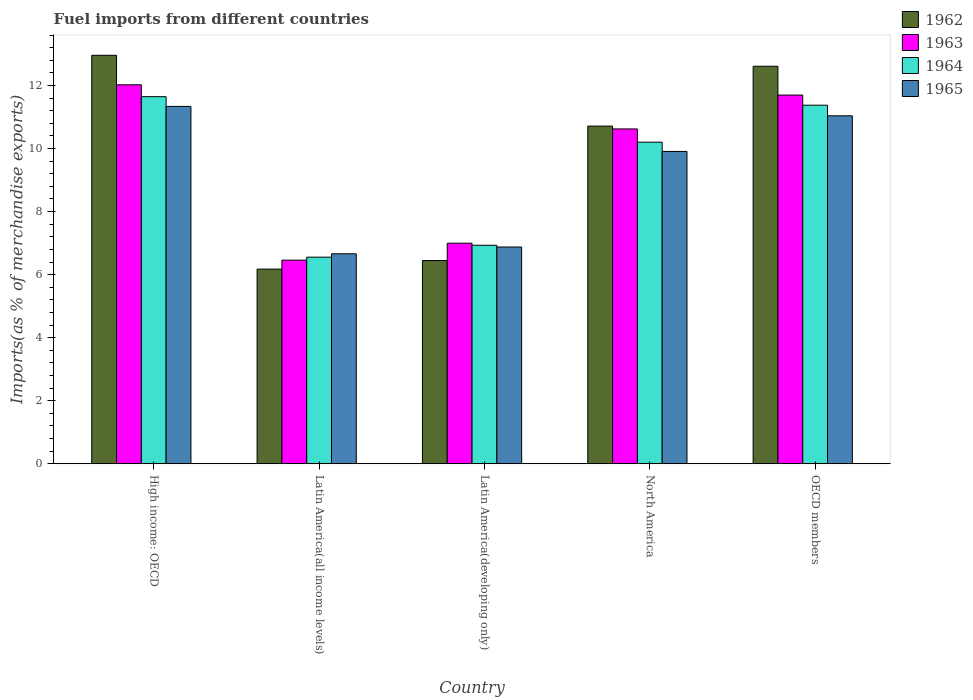How many different coloured bars are there?
Keep it short and to the point. 4. How many groups of bars are there?
Give a very brief answer. 5. Are the number of bars per tick equal to the number of legend labels?
Keep it short and to the point. Yes. How many bars are there on the 3rd tick from the right?
Give a very brief answer. 4. What is the label of the 3rd group of bars from the left?
Provide a short and direct response. Latin America(developing only). What is the percentage of imports to different countries in 1964 in Latin America(all income levels)?
Keep it short and to the point. 6.55. Across all countries, what is the maximum percentage of imports to different countries in 1963?
Offer a very short reply. 12.02. Across all countries, what is the minimum percentage of imports to different countries in 1964?
Make the answer very short. 6.55. In which country was the percentage of imports to different countries in 1963 maximum?
Provide a short and direct response. High income: OECD. In which country was the percentage of imports to different countries in 1963 minimum?
Make the answer very short. Latin America(all income levels). What is the total percentage of imports to different countries in 1965 in the graph?
Offer a terse response. 45.82. What is the difference between the percentage of imports to different countries in 1962 in High income: OECD and that in North America?
Ensure brevity in your answer.  2.25. What is the difference between the percentage of imports to different countries in 1964 in High income: OECD and the percentage of imports to different countries in 1962 in Latin America(all income levels)?
Offer a very short reply. 5.47. What is the average percentage of imports to different countries in 1962 per country?
Ensure brevity in your answer.  9.78. What is the difference between the percentage of imports to different countries of/in 1964 and percentage of imports to different countries of/in 1965 in OECD members?
Make the answer very short. 0.34. In how many countries, is the percentage of imports to different countries in 1965 greater than 9.2 %?
Your answer should be very brief. 3. What is the ratio of the percentage of imports to different countries in 1965 in High income: OECD to that in North America?
Give a very brief answer. 1.14. Is the percentage of imports to different countries in 1963 in Latin America(all income levels) less than that in OECD members?
Your response must be concise. Yes. Is the difference between the percentage of imports to different countries in 1964 in Latin America(all income levels) and North America greater than the difference between the percentage of imports to different countries in 1965 in Latin America(all income levels) and North America?
Your answer should be very brief. No. What is the difference between the highest and the second highest percentage of imports to different countries in 1965?
Your answer should be compact. 1.13. What is the difference between the highest and the lowest percentage of imports to different countries in 1964?
Offer a terse response. 5.09. In how many countries, is the percentage of imports to different countries in 1962 greater than the average percentage of imports to different countries in 1962 taken over all countries?
Provide a short and direct response. 3. Is it the case that in every country, the sum of the percentage of imports to different countries in 1963 and percentage of imports to different countries in 1964 is greater than the sum of percentage of imports to different countries in 1965 and percentage of imports to different countries in 1962?
Make the answer very short. No. What does the 3rd bar from the left in Latin America(developing only) represents?
Ensure brevity in your answer.  1964. What does the 3rd bar from the right in North America represents?
Offer a terse response. 1963. Is it the case that in every country, the sum of the percentage of imports to different countries in 1963 and percentage of imports to different countries in 1962 is greater than the percentage of imports to different countries in 1964?
Your answer should be compact. Yes. Are all the bars in the graph horizontal?
Keep it short and to the point. No. How many countries are there in the graph?
Offer a terse response. 5. What is the difference between two consecutive major ticks on the Y-axis?
Give a very brief answer. 2. Are the values on the major ticks of Y-axis written in scientific E-notation?
Make the answer very short. No. Does the graph contain grids?
Provide a short and direct response. No. Where does the legend appear in the graph?
Provide a succinct answer. Top right. What is the title of the graph?
Provide a short and direct response. Fuel imports from different countries. What is the label or title of the X-axis?
Your answer should be very brief. Country. What is the label or title of the Y-axis?
Offer a terse response. Imports(as % of merchandise exports). What is the Imports(as % of merchandise exports) of 1962 in High income: OECD?
Offer a very short reply. 12.96. What is the Imports(as % of merchandise exports) of 1963 in High income: OECD?
Offer a very short reply. 12.02. What is the Imports(as % of merchandise exports) of 1964 in High income: OECD?
Provide a succinct answer. 11.64. What is the Imports(as % of merchandise exports) of 1965 in High income: OECD?
Make the answer very short. 11.34. What is the Imports(as % of merchandise exports) of 1962 in Latin America(all income levels)?
Offer a terse response. 6.17. What is the Imports(as % of merchandise exports) of 1963 in Latin America(all income levels)?
Offer a very short reply. 6.46. What is the Imports(as % of merchandise exports) of 1964 in Latin America(all income levels)?
Your answer should be compact. 6.55. What is the Imports(as % of merchandise exports) of 1965 in Latin America(all income levels)?
Ensure brevity in your answer.  6.66. What is the Imports(as % of merchandise exports) of 1962 in Latin America(developing only)?
Your response must be concise. 6.45. What is the Imports(as % of merchandise exports) in 1963 in Latin America(developing only)?
Make the answer very short. 7. What is the Imports(as % of merchandise exports) in 1964 in Latin America(developing only)?
Make the answer very short. 6.93. What is the Imports(as % of merchandise exports) of 1965 in Latin America(developing only)?
Offer a terse response. 6.88. What is the Imports(as % of merchandise exports) of 1962 in North America?
Offer a terse response. 10.71. What is the Imports(as % of merchandise exports) of 1963 in North America?
Offer a terse response. 10.62. What is the Imports(as % of merchandise exports) in 1964 in North America?
Ensure brevity in your answer.  10.2. What is the Imports(as % of merchandise exports) in 1965 in North America?
Provide a short and direct response. 9.91. What is the Imports(as % of merchandise exports) of 1962 in OECD members?
Ensure brevity in your answer.  12.61. What is the Imports(as % of merchandise exports) of 1963 in OECD members?
Provide a short and direct response. 11.7. What is the Imports(as % of merchandise exports) in 1964 in OECD members?
Your response must be concise. 11.37. What is the Imports(as % of merchandise exports) in 1965 in OECD members?
Provide a succinct answer. 11.04. Across all countries, what is the maximum Imports(as % of merchandise exports) of 1962?
Make the answer very short. 12.96. Across all countries, what is the maximum Imports(as % of merchandise exports) of 1963?
Provide a short and direct response. 12.02. Across all countries, what is the maximum Imports(as % of merchandise exports) in 1964?
Offer a very short reply. 11.64. Across all countries, what is the maximum Imports(as % of merchandise exports) in 1965?
Keep it short and to the point. 11.34. Across all countries, what is the minimum Imports(as % of merchandise exports) in 1962?
Your response must be concise. 6.17. Across all countries, what is the minimum Imports(as % of merchandise exports) of 1963?
Your answer should be compact. 6.46. Across all countries, what is the minimum Imports(as % of merchandise exports) of 1964?
Provide a short and direct response. 6.55. Across all countries, what is the minimum Imports(as % of merchandise exports) in 1965?
Provide a succinct answer. 6.66. What is the total Imports(as % of merchandise exports) of 1962 in the graph?
Provide a succinct answer. 48.9. What is the total Imports(as % of merchandise exports) of 1963 in the graph?
Offer a very short reply. 47.79. What is the total Imports(as % of merchandise exports) of 1964 in the graph?
Offer a very short reply. 46.7. What is the total Imports(as % of merchandise exports) in 1965 in the graph?
Offer a very short reply. 45.82. What is the difference between the Imports(as % of merchandise exports) of 1962 in High income: OECD and that in Latin America(all income levels)?
Your answer should be very brief. 6.78. What is the difference between the Imports(as % of merchandise exports) in 1963 in High income: OECD and that in Latin America(all income levels)?
Keep it short and to the point. 5.56. What is the difference between the Imports(as % of merchandise exports) of 1964 in High income: OECD and that in Latin America(all income levels)?
Keep it short and to the point. 5.09. What is the difference between the Imports(as % of merchandise exports) of 1965 in High income: OECD and that in Latin America(all income levels)?
Offer a very short reply. 4.68. What is the difference between the Imports(as % of merchandise exports) of 1962 in High income: OECD and that in Latin America(developing only)?
Make the answer very short. 6.51. What is the difference between the Imports(as % of merchandise exports) of 1963 in High income: OECD and that in Latin America(developing only)?
Make the answer very short. 5.02. What is the difference between the Imports(as % of merchandise exports) in 1964 in High income: OECD and that in Latin America(developing only)?
Give a very brief answer. 4.71. What is the difference between the Imports(as % of merchandise exports) of 1965 in High income: OECD and that in Latin America(developing only)?
Keep it short and to the point. 4.46. What is the difference between the Imports(as % of merchandise exports) of 1962 in High income: OECD and that in North America?
Keep it short and to the point. 2.25. What is the difference between the Imports(as % of merchandise exports) in 1963 in High income: OECD and that in North America?
Provide a short and direct response. 1.4. What is the difference between the Imports(as % of merchandise exports) of 1964 in High income: OECD and that in North America?
Provide a succinct answer. 1.44. What is the difference between the Imports(as % of merchandise exports) of 1965 in High income: OECD and that in North America?
Make the answer very short. 1.43. What is the difference between the Imports(as % of merchandise exports) in 1962 in High income: OECD and that in OECD members?
Give a very brief answer. 0.35. What is the difference between the Imports(as % of merchandise exports) of 1963 in High income: OECD and that in OECD members?
Offer a terse response. 0.33. What is the difference between the Imports(as % of merchandise exports) in 1964 in High income: OECD and that in OECD members?
Offer a terse response. 0.27. What is the difference between the Imports(as % of merchandise exports) of 1965 in High income: OECD and that in OECD members?
Keep it short and to the point. 0.3. What is the difference between the Imports(as % of merchandise exports) in 1962 in Latin America(all income levels) and that in Latin America(developing only)?
Give a very brief answer. -0.27. What is the difference between the Imports(as % of merchandise exports) of 1963 in Latin America(all income levels) and that in Latin America(developing only)?
Make the answer very short. -0.54. What is the difference between the Imports(as % of merchandise exports) of 1964 in Latin America(all income levels) and that in Latin America(developing only)?
Your answer should be compact. -0.38. What is the difference between the Imports(as % of merchandise exports) in 1965 in Latin America(all income levels) and that in Latin America(developing only)?
Provide a succinct answer. -0.22. What is the difference between the Imports(as % of merchandise exports) in 1962 in Latin America(all income levels) and that in North America?
Your answer should be very brief. -4.54. What is the difference between the Imports(as % of merchandise exports) in 1963 in Latin America(all income levels) and that in North America?
Your answer should be very brief. -4.16. What is the difference between the Imports(as % of merchandise exports) in 1964 in Latin America(all income levels) and that in North America?
Your answer should be compact. -3.65. What is the difference between the Imports(as % of merchandise exports) in 1965 in Latin America(all income levels) and that in North America?
Offer a terse response. -3.25. What is the difference between the Imports(as % of merchandise exports) of 1962 in Latin America(all income levels) and that in OECD members?
Keep it short and to the point. -6.44. What is the difference between the Imports(as % of merchandise exports) of 1963 in Latin America(all income levels) and that in OECD members?
Your response must be concise. -5.24. What is the difference between the Imports(as % of merchandise exports) in 1964 in Latin America(all income levels) and that in OECD members?
Your answer should be very brief. -4.82. What is the difference between the Imports(as % of merchandise exports) in 1965 in Latin America(all income levels) and that in OECD members?
Make the answer very short. -4.38. What is the difference between the Imports(as % of merchandise exports) in 1962 in Latin America(developing only) and that in North America?
Your response must be concise. -4.27. What is the difference between the Imports(as % of merchandise exports) of 1963 in Latin America(developing only) and that in North America?
Provide a short and direct response. -3.63. What is the difference between the Imports(as % of merchandise exports) of 1964 in Latin America(developing only) and that in North America?
Give a very brief answer. -3.27. What is the difference between the Imports(as % of merchandise exports) in 1965 in Latin America(developing only) and that in North America?
Provide a succinct answer. -3.03. What is the difference between the Imports(as % of merchandise exports) of 1962 in Latin America(developing only) and that in OECD members?
Offer a very short reply. -6.16. What is the difference between the Imports(as % of merchandise exports) in 1963 in Latin America(developing only) and that in OECD members?
Provide a short and direct response. -4.7. What is the difference between the Imports(as % of merchandise exports) of 1964 in Latin America(developing only) and that in OECD members?
Offer a very short reply. -4.44. What is the difference between the Imports(as % of merchandise exports) of 1965 in Latin America(developing only) and that in OECD members?
Your answer should be very brief. -4.16. What is the difference between the Imports(as % of merchandise exports) in 1962 in North America and that in OECD members?
Offer a terse response. -1.9. What is the difference between the Imports(as % of merchandise exports) of 1963 in North America and that in OECD members?
Provide a succinct answer. -1.07. What is the difference between the Imports(as % of merchandise exports) of 1964 in North America and that in OECD members?
Provide a succinct answer. -1.17. What is the difference between the Imports(as % of merchandise exports) in 1965 in North America and that in OECD members?
Provide a succinct answer. -1.13. What is the difference between the Imports(as % of merchandise exports) of 1962 in High income: OECD and the Imports(as % of merchandise exports) of 1963 in Latin America(all income levels)?
Offer a very short reply. 6.5. What is the difference between the Imports(as % of merchandise exports) of 1962 in High income: OECD and the Imports(as % of merchandise exports) of 1964 in Latin America(all income levels)?
Give a very brief answer. 6.4. What is the difference between the Imports(as % of merchandise exports) of 1962 in High income: OECD and the Imports(as % of merchandise exports) of 1965 in Latin America(all income levels)?
Your response must be concise. 6.3. What is the difference between the Imports(as % of merchandise exports) of 1963 in High income: OECD and the Imports(as % of merchandise exports) of 1964 in Latin America(all income levels)?
Your answer should be very brief. 5.47. What is the difference between the Imports(as % of merchandise exports) of 1963 in High income: OECD and the Imports(as % of merchandise exports) of 1965 in Latin America(all income levels)?
Your answer should be very brief. 5.36. What is the difference between the Imports(as % of merchandise exports) of 1964 in High income: OECD and the Imports(as % of merchandise exports) of 1965 in Latin America(all income levels)?
Keep it short and to the point. 4.98. What is the difference between the Imports(as % of merchandise exports) of 1962 in High income: OECD and the Imports(as % of merchandise exports) of 1963 in Latin America(developing only)?
Make the answer very short. 5.96. What is the difference between the Imports(as % of merchandise exports) of 1962 in High income: OECD and the Imports(as % of merchandise exports) of 1964 in Latin America(developing only)?
Ensure brevity in your answer.  6.03. What is the difference between the Imports(as % of merchandise exports) in 1962 in High income: OECD and the Imports(as % of merchandise exports) in 1965 in Latin America(developing only)?
Make the answer very short. 6.08. What is the difference between the Imports(as % of merchandise exports) of 1963 in High income: OECD and the Imports(as % of merchandise exports) of 1964 in Latin America(developing only)?
Your response must be concise. 5.09. What is the difference between the Imports(as % of merchandise exports) of 1963 in High income: OECD and the Imports(as % of merchandise exports) of 1965 in Latin America(developing only)?
Offer a very short reply. 5.15. What is the difference between the Imports(as % of merchandise exports) in 1964 in High income: OECD and the Imports(as % of merchandise exports) in 1965 in Latin America(developing only)?
Offer a terse response. 4.77. What is the difference between the Imports(as % of merchandise exports) in 1962 in High income: OECD and the Imports(as % of merchandise exports) in 1963 in North America?
Offer a terse response. 2.34. What is the difference between the Imports(as % of merchandise exports) in 1962 in High income: OECD and the Imports(as % of merchandise exports) in 1964 in North America?
Offer a very short reply. 2.76. What is the difference between the Imports(as % of merchandise exports) of 1962 in High income: OECD and the Imports(as % of merchandise exports) of 1965 in North America?
Your answer should be compact. 3.05. What is the difference between the Imports(as % of merchandise exports) of 1963 in High income: OECD and the Imports(as % of merchandise exports) of 1964 in North America?
Keep it short and to the point. 1.82. What is the difference between the Imports(as % of merchandise exports) in 1963 in High income: OECD and the Imports(as % of merchandise exports) in 1965 in North America?
Provide a succinct answer. 2.11. What is the difference between the Imports(as % of merchandise exports) in 1964 in High income: OECD and the Imports(as % of merchandise exports) in 1965 in North America?
Your answer should be very brief. 1.74. What is the difference between the Imports(as % of merchandise exports) in 1962 in High income: OECD and the Imports(as % of merchandise exports) in 1963 in OECD members?
Give a very brief answer. 1.26. What is the difference between the Imports(as % of merchandise exports) of 1962 in High income: OECD and the Imports(as % of merchandise exports) of 1964 in OECD members?
Your answer should be very brief. 1.58. What is the difference between the Imports(as % of merchandise exports) of 1962 in High income: OECD and the Imports(as % of merchandise exports) of 1965 in OECD members?
Give a very brief answer. 1.92. What is the difference between the Imports(as % of merchandise exports) of 1963 in High income: OECD and the Imports(as % of merchandise exports) of 1964 in OECD members?
Your answer should be very brief. 0.65. What is the difference between the Imports(as % of merchandise exports) in 1963 in High income: OECD and the Imports(as % of merchandise exports) in 1965 in OECD members?
Make the answer very short. 0.98. What is the difference between the Imports(as % of merchandise exports) of 1964 in High income: OECD and the Imports(as % of merchandise exports) of 1965 in OECD members?
Provide a succinct answer. 0.61. What is the difference between the Imports(as % of merchandise exports) of 1962 in Latin America(all income levels) and the Imports(as % of merchandise exports) of 1963 in Latin America(developing only)?
Offer a terse response. -0.82. What is the difference between the Imports(as % of merchandise exports) in 1962 in Latin America(all income levels) and the Imports(as % of merchandise exports) in 1964 in Latin America(developing only)?
Your answer should be compact. -0.76. What is the difference between the Imports(as % of merchandise exports) of 1962 in Latin America(all income levels) and the Imports(as % of merchandise exports) of 1965 in Latin America(developing only)?
Keep it short and to the point. -0.7. What is the difference between the Imports(as % of merchandise exports) of 1963 in Latin America(all income levels) and the Imports(as % of merchandise exports) of 1964 in Latin America(developing only)?
Keep it short and to the point. -0.47. What is the difference between the Imports(as % of merchandise exports) in 1963 in Latin America(all income levels) and the Imports(as % of merchandise exports) in 1965 in Latin America(developing only)?
Give a very brief answer. -0.42. What is the difference between the Imports(as % of merchandise exports) in 1964 in Latin America(all income levels) and the Imports(as % of merchandise exports) in 1965 in Latin America(developing only)?
Offer a terse response. -0.32. What is the difference between the Imports(as % of merchandise exports) of 1962 in Latin America(all income levels) and the Imports(as % of merchandise exports) of 1963 in North America?
Provide a short and direct response. -4.45. What is the difference between the Imports(as % of merchandise exports) of 1962 in Latin America(all income levels) and the Imports(as % of merchandise exports) of 1964 in North America?
Keep it short and to the point. -4.03. What is the difference between the Imports(as % of merchandise exports) in 1962 in Latin America(all income levels) and the Imports(as % of merchandise exports) in 1965 in North America?
Your answer should be very brief. -3.73. What is the difference between the Imports(as % of merchandise exports) in 1963 in Latin America(all income levels) and the Imports(as % of merchandise exports) in 1964 in North America?
Offer a terse response. -3.74. What is the difference between the Imports(as % of merchandise exports) in 1963 in Latin America(all income levels) and the Imports(as % of merchandise exports) in 1965 in North America?
Your answer should be very brief. -3.45. What is the difference between the Imports(as % of merchandise exports) of 1964 in Latin America(all income levels) and the Imports(as % of merchandise exports) of 1965 in North America?
Your answer should be very brief. -3.35. What is the difference between the Imports(as % of merchandise exports) in 1962 in Latin America(all income levels) and the Imports(as % of merchandise exports) in 1963 in OECD members?
Offer a very short reply. -5.52. What is the difference between the Imports(as % of merchandise exports) of 1962 in Latin America(all income levels) and the Imports(as % of merchandise exports) of 1964 in OECD members?
Offer a terse response. -5.2. What is the difference between the Imports(as % of merchandise exports) in 1962 in Latin America(all income levels) and the Imports(as % of merchandise exports) in 1965 in OECD members?
Offer a terse response. -4.86. What is the difference between the Imports(as % of merchandise exports) in 1963 in Latin America(all income levels) and the Imports(as % of merchandise exports) in 1964 in OECD members?
Make the answer very short. -4.92. What is the difference between the Imports(as % of merchandise exports) of 1963 in Latin America(all income levels) and the Imports(as % of merchandise exports) of 1965 in OECD members?
Give a very brief answer. -4.58. What is the difference between the Imports(as % of merchandise exports) in 1964 in Latin America(all income levels) and the Imports(as % of merchandise exports) in 1965 in OECD members?
Provide a short and direct response. -4.48. What is the difference between the Imports(as % of merchandise exports) in 1962 in Latin America(developing only) and the Imports(as % of merchandise exports) in 1963 in North America?
Offer a terse response. -4.17. What is the difference between the Imports(as % of merchandise exports) in 1962 in Latin America(developing only) and the Imports(as % of merchandise exports) in 1964 in North America?
Provide a succinct answer. -3.75. What is the difference between the Imports(as % of merchandise exports) of 1962 in Latin America(developing only) and the Imports(as % of merchandise exports) of 1965 in North America?
Keep it short and to the point. -3.46. What is the difference between the Imports(as % of merchandise exports) in 1963 in Latin America(developing only) and the Imports(as % of merchandise exports) in 1964 in North America?
Give a very brief answer. -3.2. What is the difference between the Imports(as % of merchandise exports) in 1963 in Latin America(developing only) and the Imports(as % of merchandise exports) in 1965 in North America?
Keep it short and to the point. -2.91. What is the difference between the Imports(as % of merchandise exports) in 1964 in Latin America(developing only) and the Imports(as % of merchandise exports) in 1965 in North America?
Provide a short and direct response. -2.98. What is the difference between the Imports(as % of merchandise exports) in 1962 in Latin America(developing only) and the Imports(as % of merchandise exports) in 1963 in OECD members?
Your answer should be very brief. -5.25. What is the difference between the Imports(as % of merchandise exports) in 1962 in Latin America(developing only) and the Imports(as % of merchandise exports) in 1964 in OECD members?
Provide a short and direct response. -4.93. What is the difference between the Imports(as % of merchandise exports) of 1962 in Latin America(developing only) and the Imports(as % of merchandise exports) of 1965 in OECD members?
Your answer should be very brief. -4.59. What is the difference between the Imports(as % of merchandise exports) of 1963 in Latin America(developing only) and the Imports(as % of merchandise exports) of 1964 in OECD members?
Give a very brief answer. -4.38. What is the difference between the Imports(as % of merchandise exports) in 1963 in Latin America(developing only) and the Imports(as % of merchandise exports) in 1965 in OECD members?
Offer a very short reply. -4.04. What is the difference between the Imports(as % of merchandise exports) in 1964 in Latin America(developing only) and the Imports(as % of merchandise exports) in 1965 in OECD members?
Provide a short and direct response. -4.11. What is the difference between the Imports(as % of merchandise exports) in 1962 in North America and the Imports(as % of merchandise exports) in 1963 in OECD members?
Your answer should be very brief. -0.98. What is the difference between the Imports(as % of merchandise exports) in 1962 in North America and the Imports(as % of merchandise exports) in 1964 in OECD members?
Make the answer very short. -0.66. What is the difference between the Imports(as % of merchandise exports) in 1962 in North America and the Imports(as % of merchandise exports) in 1965 in OECD members?
Your response must be concise. -0.33. What is the difference between the Imports(as % of merchandise exports) in 1963 in North America and the Imports(as % of merchandise exports) in 1964 in OECD members?
Give a very brief answer. -0.75. What is the difference between the Imports(as % of merchandise exports) of 1963 in North America and the Imports(as % of merchandise exports) of 1965 in OECD members?
Your answer should be compact. -0.42. What is the difference between the Imports(as % of merchandise exports) in 1964 in North America and the Imports(as % of merchandise exports) in 1965 in OECD members?
Offer a terse response. -0.84. What is the average Imports(as % of merchandise exports) of 1962 per country?
Provide a succinct answer. 9.78. What is the average Imports(as % of merchandise exports) of 1963 per country?
Your answer should be very brief. 9.56. What is the average Imports(as % of merchandise exports) in 1964 per country?
Provide a succinct answer. 9.34. What is the average Imports(as % of merchandise exports) of 1965 per country?
Your answer should be very brief. 9.16. What is the difference between the Imports(as % of merchandise exports) of 1962 and Imports(as % of merchandise exports) of 1963 in High income: OECD?
Make the answer very short. 0.94. What is the difference between the Imports(as % of merchandise exports) in 1962 and Imports(as % of merchandise exports) in 1964 in High income: OECD?
Your answer should be very brief. 1.31. What is the difference between the Imports(as % of merchandise exports) in 1962 and Imports(as % of merchandise exports) in 1965 in High income: OECD?
Provide a succinct answer. 1.62. What is the difference between the Imports(as % of merchandise exports) in 1963 and Imports(as % of merchandise exports) in 1964 in High income: OECD?
Your answer should be very brief. 0.38. What is the difference between the Imports(as % of merchandise exports) of 1963 and Imports(as % of merchandise exports) of 1965 in High income: OECD?
Your answer should be very brief. 0.69. What is the difference between the Imports(as % of merchandise exports) of 1964 and Imports(as % of merchandise exports) of 1965 in High income: OECD?
Keep it short and to the point. 0.31. What is the difference between the Imports(as % of merchandise exports) in 1962 and Imports(as % of merchandise exports) in 1963 in Latin America(all income levels)?
Your answer should be compact. -0.28. What is the difference between the Imports(as % of merchandise exports) in 1962 and Imports(as % of merchandise exports) in 1964 in Latin America(all income levels)?
Provide a short and direct response. -0.38. What is the difference between the Imports(as % of merchandise exports) in 1962 and Imports(as % of merchandise exports) in 1965 in Latin America(all income levels)?
Your answer should be very brief. -0.48. What is the difference between the Imports(as % of merchandise exports) of 1963 and Imports(as % of merchandise exports) of 1964 in Latin America(all income levels)?
Provide a succinct answer. -0.09. What is the difference between the Imports(as % of merchandise exports) in 1963 and Imports(as % of merchandise exports) in 1965 in Latin America(all income levels)?
Make the answer very short. -0.2. What is the difference between the Imports(as % of merchandise exports) in 1964 and Imports(as % of merchandise exports) in 1965 in Latin America(all income levels)?
Offer a terse response. -0.11. What is the difference between the Imports(as % of merchandise exports) in 1962 and Imports(as % of merchandise exports) in 1963 in Latin America(developing only)?
Your response must be concise. -0.55. What is the difference between the Imports(as % of merchandise exports) of 1962 and Imports(as % of merchandise exports) of 1964 in Latin America(developing only)?
Provide a short and direct response. -0.48. What is the difference between the Imports(as % of merchandise exports) in 1962 and Imports(as % of merchandise exports) in 1965 in Latin America(developing only)?
Offer a terse response. -0.43. What is the difference between the Imports(as % of merchandise exports) in 1963 and Imports(as % of merchandise exports) in 1964 in Latin America(developing only)?
Your answer should be very brief. 0.07. What is the difference between the Imports(as % of merchandise exports) of 1963 and Imports(as % of merchandise exports) of 1965 in Latin America(developing only)?
Provide a succinct answer. 0.12. What is the difference between the Imports(as % of merchandise exports) of 1964 and Imports(as % of merchandise exports) of 1965 in Latin America(developing only)?
Provide a short and direct response. 0.06. What is the difference between the Imports(as % of merchandise exports) of 1962 and Imports(as % of merchandise exports) of 1963 in North America?
Offer a very short reply. 0.09. What is the difference between the Imports(as % of merchandise exports) in 1962 and Imports(as % of merchandise exports) in 1964 in North America?
Your answer should be very brief. 0.51. What is the difference between the Imports(as % of merchandise exports) of 1962 and Imports(as % of merchandise exports) of 1965 in North America?
Offer a terse response. 0.8. What is the difference between the Imports(as % of merchandise exports) in 1963 and Imports(as % of merchandise exports) in 1964 in North America?
Give a very brief answer. 0.42. What is the difference between the Imports(as % of merchandise exports) of 1963 and Imports(as % of merchandise exports) of 1965 in North America?
Offer a terse response. 0.71. What is the difference between the Imports(as % of merchandise exports) of 1964 and Imports(as % of merchandise exports) of 1965 in North America?
Provide a succinct answer. 0.29. What is the difference between the Imports(as % of merchandise exports) of 1962 and Imports(as % of merchandise exports) of 1963 in OECD members?
Offer a terse response. 0.91. What is the difference between the Imports(as % of merchandise exports) in 1962 and Imports(as % of merchandise exports) in 1964 in OECD members?
Offer a terse response. 1.24. What is the difference between the Imports(as % of merchandise exports) in 1962 and Imports(as % of merchandise exports) in 1965 in OECD members?
Give a very brief answer. 1.57. What is the difference between the Imports(as % of merchandise exports) of 1963 and Imports(as % of merchandise exports) of 1964 in OECD members?
Provide a succinct answer. 0.32. What is the difference between the Imports(as % of merchandise exports) in 1963 and Imports(as % of merchandise exports) in 1965 in OECD members?
Your answer should be compact. 0.66. What is the difference between the Imports(as % of merchandise exports) of 1964 and Imports(as % of merchandise exports) of 1965 in OECD members?
Your answer should be compact. 0.34. What is the ratio of the Imports(as % of merchandise exports) of 1962 in High income: OECD to that in Latin America(all income levels)?
Provide a succinct answer. 2.1. What is the ratio of the Imports(as % of merchandise exports) of 1963 in High income: OECD to that in Latin America(all income levels)?
Provide a short and direct response. 1.86. What is the ratio of the Imports(as % of merchandise exports) of 1964 in High income: OECD to that in Latin America(all income levels)?
Your answer should be very brief. 1.78. What is the ratio of the Imports(as % of merchandise exports) of 1965 in High income: OECD to that in Latin America(all income levels)?
Offer a very short reply. 1.7. What is the ratio of the Imports(as % of merchandise exports) of 1962 in High income: OECD to that in Latin America(developing only)?
Offer a very short reply. 2.01. What is the ratio of the Imports(as % of merchandise exports) in 1963 in High income: OECD to that in Latin America(developing only)?
Your answer should be very brief. 1.72. What is the ratio of the Imports(as % of merchandise exports) in 1964 in High income: OECD to that in Latin America(developing only)?
Keep it short and to the point. 1.68. What is the ratio of the Imports(as % of merchandise exports) of 1965 in High income: OECD to that in Latin America(developing only)?
Make the answer very short. 1.65. What is the ratio of the Imports(as % of merchandise exports) in 1962 in High income: OECD to that in North America?
Offer a terse response. 1.21. What is the ratio of the Imports(as % of merchandise exports) of 1963 in High income: OECD to that in North America?
Offer a terse response. 1.13. What is the ratio of the Imports(as % of merchandise exports) of 1964 in High income: OECD to that in North America?
Ensure brevity in your answer.  1.14. What is the ratio of the Imports(as % of merchandise exports) in 1965 in High income: OECD to that in North America?
Provide a short and direct response. 1.14. What is the ratio of the Imports(as % of merchandise exports) of 1962 in High income: OECD to that in OECD members?
Give a very brief answer. 1.03. What is the ratio of the Imports(as % of merchandise exports) of 1963 in High income: OECD to that in OECD members?
Your answer should be very brief. 1.03. What is the ratio of the Imports(as % of merchandise exports) in 1964 in High income: OECD to that in OECD members?
Offer a terse response. 1.02. What is the ratio of the Imports(as % of merchandise exports) in 1962 in Latin America(all income levels) to that in Latin America(developing only)?
Provide a short and direct response. 0.96. What is the ratio of the Imports(as % of merchandise exports) of 1963 in Latin America(all income levels) to that in Latin America(developing only)?
Offer a terse response. 0.92. What is the ratio of the Imports(as % of merchandise exports) of 1964 in Latin America(all income levels) to that in Latin America(developing only)?
Provide a succinct answer. 0.95. What is the ratio of the Imports(as % of merchandise exports) of 1965 in Latin America(all income levels) to that in Latin America(developing only)?
Your answer should be compact. 0.97. What is the ratio of the Imports(as % of merchandise exports) in 1962 in Latin America(all income levels) to that in North America?
Ensure brevity in your answer.  0.58. What is the ratio of the Imports(as % of merchandise exports) in 1963 in Latin America(all income levels) to that in North America?
Ensure brevity in your answer.  0.61. What is the ratio of the Imports(as % of merchandise exports) of 1964 in Latin America(all income levels) to that in North America?
Provide a short and direct response. 0.64. What is the ratio of the Imports(as % of merchandise exports) in 1965 in Latin America(all income levels) to that in North America?
Offer a terse response. 0.67. What is the ratio of the Imports(as % of merchandise exports) of 1962 in Latin America(all income levels) to that in OECD members?
Make the answer very short. 0.49. What is the ratio of the Imports(as % of merchandise exports) of 1963 in Latin America(all income levels) to that in OECD members?
Your answer should be compact. 0.55. What is the ratio of the Imports(as % of merchandise exports) of 1964 in Latin America(all income levels) to that in OECD members?
Offer a very short reply. 0.58. What is the ratio of the Imports(as % of merchandise exports) in 1965 in Latin America(all income levels) to that in OECD members?
Ensure brevity in your answer.  0.6. What is the ratio of the Imports(as % of merchandise exports) in 1962 in Latin America(developing only) to that in North America?
Give a very brief answer. 0.6. What is the ratio of the Imports(as % of merchandise exports) in 1963 in Latin America(developing only) to that in North America?
Offer a very short reply. 0.66. What is the ratio of the Imports(as % of merchandise exports) in 1964 in Latin America(developing only) to that in North America?
Provide a short and direct response. 0.68. What is the ratio of the Imports(as % of merchandise exports) in 1965 in Latin America(developing only) to that in North America?
Offer a very short reply. 0.69. What is the ratio of the Imports(as % of merchandise exports) in 1962 in Latin America(developing only) to that in OECD members?
Your answer should be compact. 0.51. What is the ratio of the Imports(as % of merchandise exports) of 1963 in Latin America(developing only) to that in OECD members?
Keep it short and to the point. 0.6. What is the ratio of the Imports(as % of merchandise exports) of 1964 in Latin America(developing only) to that in OECD members?
Your answer should be compact. 0.61. What is the ratio of the Imports(as % of merchandise exports) in 1965 in Latin America(developing only) to that in OECD members?
Make the answer very short. 0.62. What is the ratio of the Imports(as % of merchandise exports) in 1962 in North America to that in OECD members?
Make the answer very short. 0.85. What is the ratio of the Imports(as % of merchandise exports) in 1963 in North America to that in OECD members?
Offer a terse response. 0.91. What is the ratio of the Imports(as % of merchandise exports) in 1964 in North America to that in OECD members?
Your answer should be very brief. 0.9. What is the ratio of the Imports(as % of merchandise exports) in 1965 in North America to that in OECD members?
Your response must be concise. 0.9. What is the difference between the highest and the second highest Imports(as % of merchandise exports) of 1962?
Provide a succinct answer. 0.35. What is the difference between the highest and the second highest Imports(as % of merchandise exports) in 1963?
Make the answer very short. 0.33. What is the difference between the highest and the second highest Imports(as % of merchandise exports) in 1964?
Provide a short and direct response. 0.27. What is the difference between the highest and the second highest Imports(as % of merchandise exports) in 1965?
Offer a very short reply. 0.3. What is the difference between the highest and the lowest Imports(as % of merchandise exports) in 1962?
Make the answer very short. 6.78. What is the difference between the highest and the lowest Imports(as % of merchandise exports) in 1963?
Ensure brevity in your answer.  5.56. What is the difference between the highest and the lowest Imports(as % of merchandise exports) of 1964?
Offer a terse response. 5.09. What is the difference between the highest and the lowest Imports(as % of merchandise exports) in 1965?
Your answer should be compact. 4.68. 